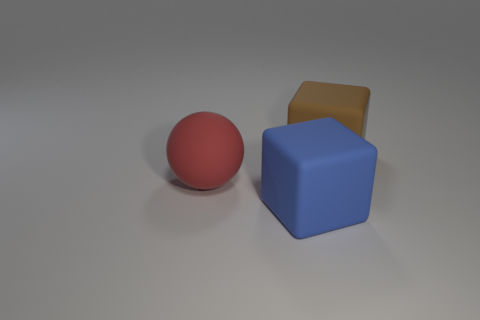Subtract all blue blocks. How many blocks are left? 1 Subtract 1 balls. How many balls are left? 0 Add 3 small brown metal blocks. How many small brown metal blocks exist? 3 Add 2 matte spheres. How many objects exist? 5 Subtract 1 brown cubes. How many objects are left? 2 Subtract all blocks. How many objects are left? 1 Subtract all yellow cubes. Subtract all red cylinders. How many cubes are left? 2 Subtract all gray spheres. How many brown blocks are left? 1 Subtract all purple balls. Subtract all large brown things. How many objects are left? 2 Add 2 brown blocks. How many brown blocks are left? 3 